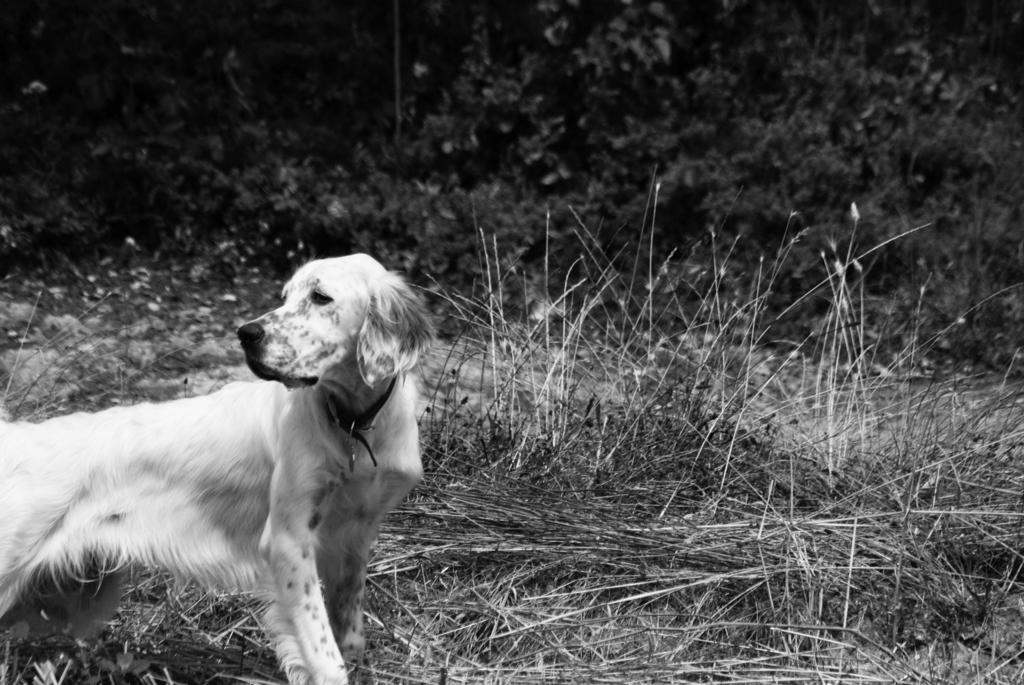What type of animal is in the image? There is a dog in the image. What is the dog's position in the image? The dog is standing on the ground. What can be seen in the background of the image? There are plants and grass in the background of the image. What is the color scheme of the image? The image is black and white in color. What year is depicted in the image? The image does not depict a specific year, as it is a black and white photograph of a dog standing on the ground with plants and grass in the background. What type of transport is visible in the image? There is no transport visible in the image; it features a dog standing on the ground with plants and grass in the background. 